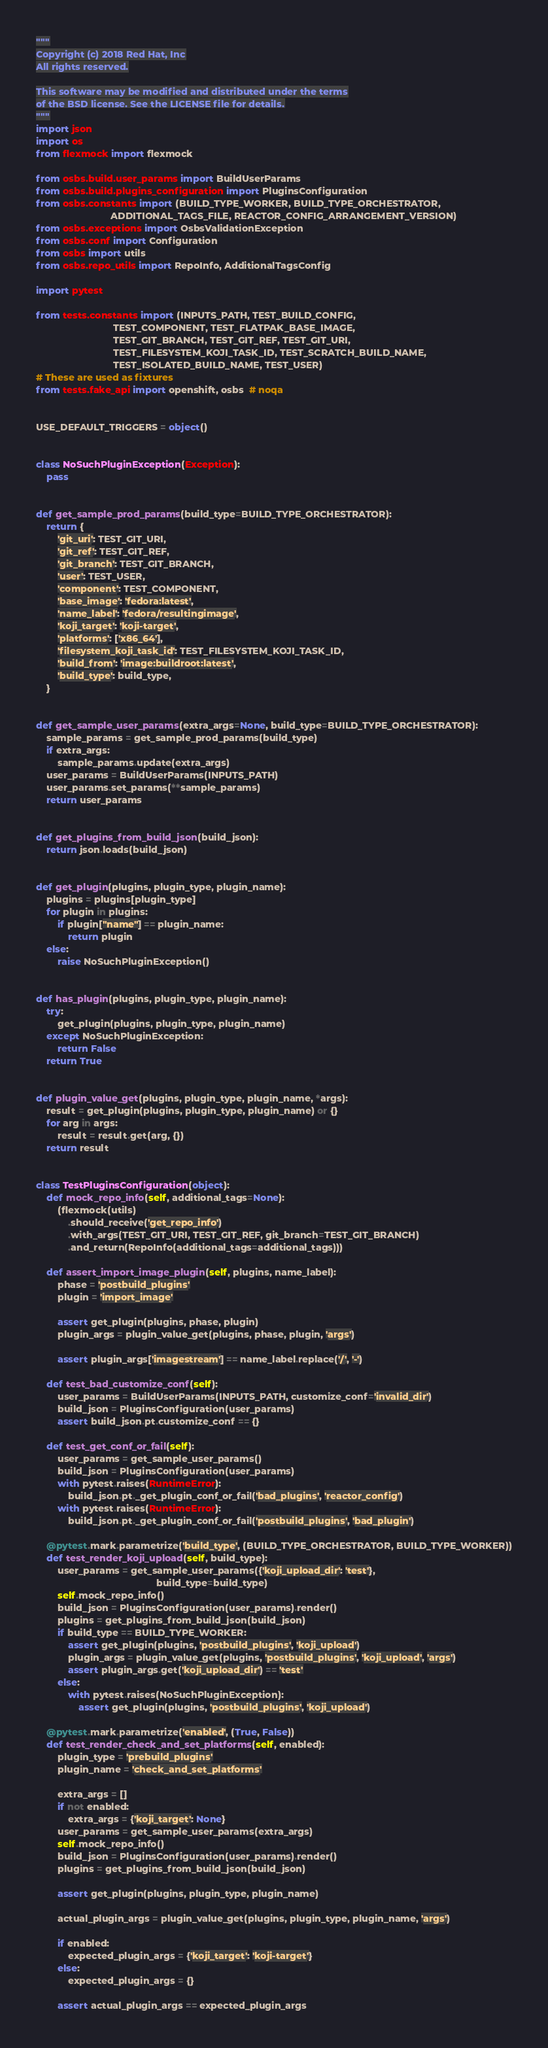<code> <loc_0><loc_0><loc_500><loc_500><_Python_>"""
Copyright (c) 2018 Red Hat, Inc
All rights reserved.

This software may be modified and distributed under the terms
of the BSD license. See the LICENSE file for details.
"""
import json
import os
from flexmock import flexmock

from osbs.build.user_params import BuildUserParams
from osbs.build.plugins_configuration import PluginsConfiguration
from osbs.constants import (BUILD_TYPE_WORKER, BUILD_TYPE_ORCHESTRATOR,
                            ADDITIONAL_TAGS_FILE, REACTOR_CONFIG_ARRANGEMENT_VERSION)
from osbs.exceptions import OsbsValidationException
from osbs.conf import Configuration
from osbs import utils
from osbs.repo_utils import RepoInfo, AdditionalTagsConfig

import pytest

from tests.constants import (INPUTS_PATH, TEST_BUILD_CONFIG,
                             TEST_COMPONENT, TEST_FLATPAK_BASE_IMAGE,
                             TEST_GIT_BRANCH, TEST_GIT_REF, TEST_GIT_URI,
                             TEST_FILESYSTEM_KOJI_TASK_ID, TEST_SCRATCH_BUILD_NAME,
                             TEST_ISOLATED_BUILD_NAME, TEST_USER)
# These are used as fixtures
from tests.fake_api import openshift, osbs  # noqa


USE_DEFAULT_TRIGGERS = object()


class NoSuchPluginException(Exception):
    pass


def get_sample_prod_params(build_type=BUILD_TYPE_ORCHESTRATOR):
    return {
        'git_uri': TEST_GIT_URI,
        'git_ref': TEST_GIT_REF,
        'git_branch': TEST_GIT_BRANCH,
        'user': TEST_USER,
        'component': TEST_COMPONENT,
        'base_image': 'fedora:latest',
        'name_label': 'fedora/resultingimage',
        'koji_target': 'koji-target',
        'platforms': ['x86_64'],
        'filesystem_koji_task_id': TEST_FILESYSTEM_KOJI_TASK_ID,
        'build_from': 'image:buildroot:latest',
        'build_type': build_type,
    }


def get_sample_user_params(extra_args=None, build_type=BUILD_TYPE_ORCHESTRATOR):
    sample_params = get_sample_prod_params(build_type)
    if extra_args:
        sample_params.update(extra_args)
    user_params = BuildUserParams(INPUTS_PATH)
    user_params.set_params(**sample_params)
    return user_params


def get_plugins_from_build_json(build_json):
    return json.loads(build_json)


def get_plugin(plugins, plugin_type, plugin_name):
    plugins = plugins[plugin_type]
    for plugin in plugins:
        if plugin["name"] == plugin_name:
            return plugin
    else:
        raise NoSuchPluginException()


def has_plugin(plugins, plugin_type, plugin_name):
    try:
        get_plugin(plugins, plugin_type, plugin_name)
    except NoSuchPluginException:
        return False
    return True


def plugin_value_get(plugins, plugin_type, plugin_name, *args):
    result = get_plugin(plugins, plugin_type, plugin_name) or {}
    for arg in args:
        result = result.get(arg, {})
    return result


class TestPluginsConfiguration(object):
    def mock_repo_info(self, additional_tags=None):
        (flexmock(utils)
            .should_receive('get_repo_info')
            .with_args(TEST_GIT_URI, TEST_GIT_REF, git_branch=TEST_GIT_BRANCH)
            .and_return(RepoInfo(additional_tags=additional_tags)))

    def assert_import_image_plugin(self, plugins, name_label):
        phase = 'postbuild_plugins'
        plugin = 'import_image'

        assert get_plugin(plugins, phase, plugin)
        plugin_args = plugin_value_get(plugins, phase, plugin, 'args')

        assert plugin_args['imagestream'] == name_label.replace('/', '-')

    def test_bad_customize_conf(self):
        user_params = BuildUserParams(INPUTS_PATH, customize_conf='invalid_dir')
        build_json = PluginsConfiguration(user_params)
        assert build_json.pt.customize_conf == {}

    def test_get_conf_or_fail(self):
        user_params = get_sample_user_params()
        build_json = PluginsConfiguration(user_params)
        with pytest.raises(RuntimeError):
            build_json.pt._get_plugin_conf_or_fail('bad_plugins', 'reactor_config')
        with pytest.raises(RuntimeError):
            build_json.pt._get_plugin_conf_or_fail('postbuild_plugins', 'bad_plugin')

    @pytest.mark.parametrize('build_type', (BUILD_TYPE_ORCHESTRATOR, BUILD_TYPE_WORKER))
    def test_render_koji_upload(self, build_type):
        user_params = get_sample_user_params({'koji_upload_dir': 'test'},
                                             build_type=build_type)
        self.mock_repo_info()
        build_json = PluginsConfiguration(user_params).render()
        plugins = get_plugins_from_build_json(build_json)
        if build_type == BUILD_TYPE_WORKER:
            assert get_plugin(plugins, 'postbuild_plugins', 'koji_upload')
            plugin_args = plugin_value_get(plugins, 'postbuild_plugins', 'koji_upload', 'args')
            assert plugin_args.get('koji_upload_dir') == 'test'
        else:
            with pytest.raises(NoSuchPluginException):
                assert get_plugin(plugins, 'postbuild_plugins', 'koji_upload')

    @pytest.mark.parametrize('enabled', (True, False))
    def test_render_check_and_set_platforms(self, enabled):
        plugin_type = 'prebuild_plugins'
        plugin_name = 'check_and_set_platforms'

        extra_args = []
        if not enabled:
            extra_args = {'koji_target': None}
        user_params = get_sample_user_params(extra_args)
        self.mock_repo_info()
        build_json = PluginsConfiguration(user_params).render()
        plugins = get_plugins_from_build_json(build_json)

        assert get_plugin(plugins, plugin_type, plugin_name)

        actual_plugin_args = plugin_value_get(plugins, plugin_type, plugin_name, 'args')

        if enabled:
            expected_plugin_args = {'koji_target': 'koji-target'}
        else:
            expected_plugin_args = {}

        assert actual_plugin_args == expected_plugin_args
</code> 